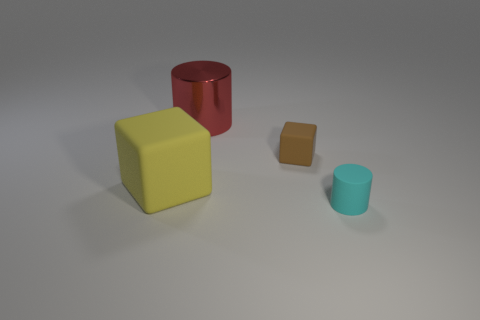There is a small thing behind the big yellow object; what number of small cyan rubber things are in front of it?
Your response must be concise. 1. Is the shape of the large yellow matte object the same as the metal object?
Your answer should be very brief. No. Is there anything else that has the same color as the small matte block?
Keep it short and to the point. No. There is a big metal object; is it the same shape as the large rubber object behind the cyan cylinder?
Give a very brief answer. No. There is a cylinder that is behind the rubber block that is on the left side of the cylinder that is to the left of the cyan matte object; what is its color?
Ensure brevity in your answer.  Red. Is there any other thing that is made of the same material as the big yellow block?
Your answer should be compact. Yes. Is the shape of the tiny object to the left of the tiny rubber cylinder the same as  the red thing?
Your response must be concise. No. What is the material of the cyan object?
Offer a very short reply. Rubber. There is a thing in front of the rubber block that is left of the small thing behind the yellow rubber cube; what shape is it?
Your answer should be compact. Cylinder. What number of other things are the same shape as the red metal object?
Provide a succinct answer. 1. 